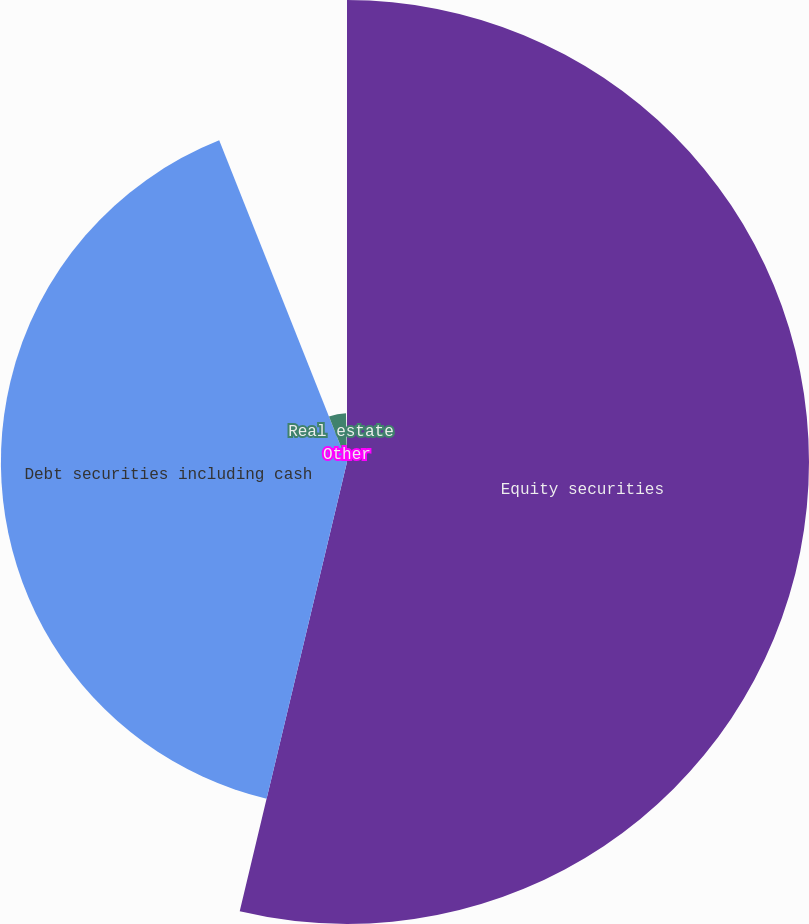Convert chart. <chart><loc_0><loc_0><loc_500><loc_500><pie_chart><fcel>Equity securities<fcel>Debt securities including cash<fcel>Real estate<fcel>Other<nl><fcel>53.73%<fcel>40.25%<fcel>5.68%<fcel>0.34%<nl></chart> 